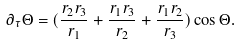<formula> <loc_0><loc_0><loc_500><loc_500>\partial _ { \tau } \Theta = ( \frac { r _ { 2 } r _ { 3 } } { r _ { 1 } } + \frac { r _ { 1 } r _ { 3 } } { r _ { 2 } } + \frac { r _ { 1 } r _ { 2 } } { r _ { 3 } } ) \cos \Theta .</formula> 